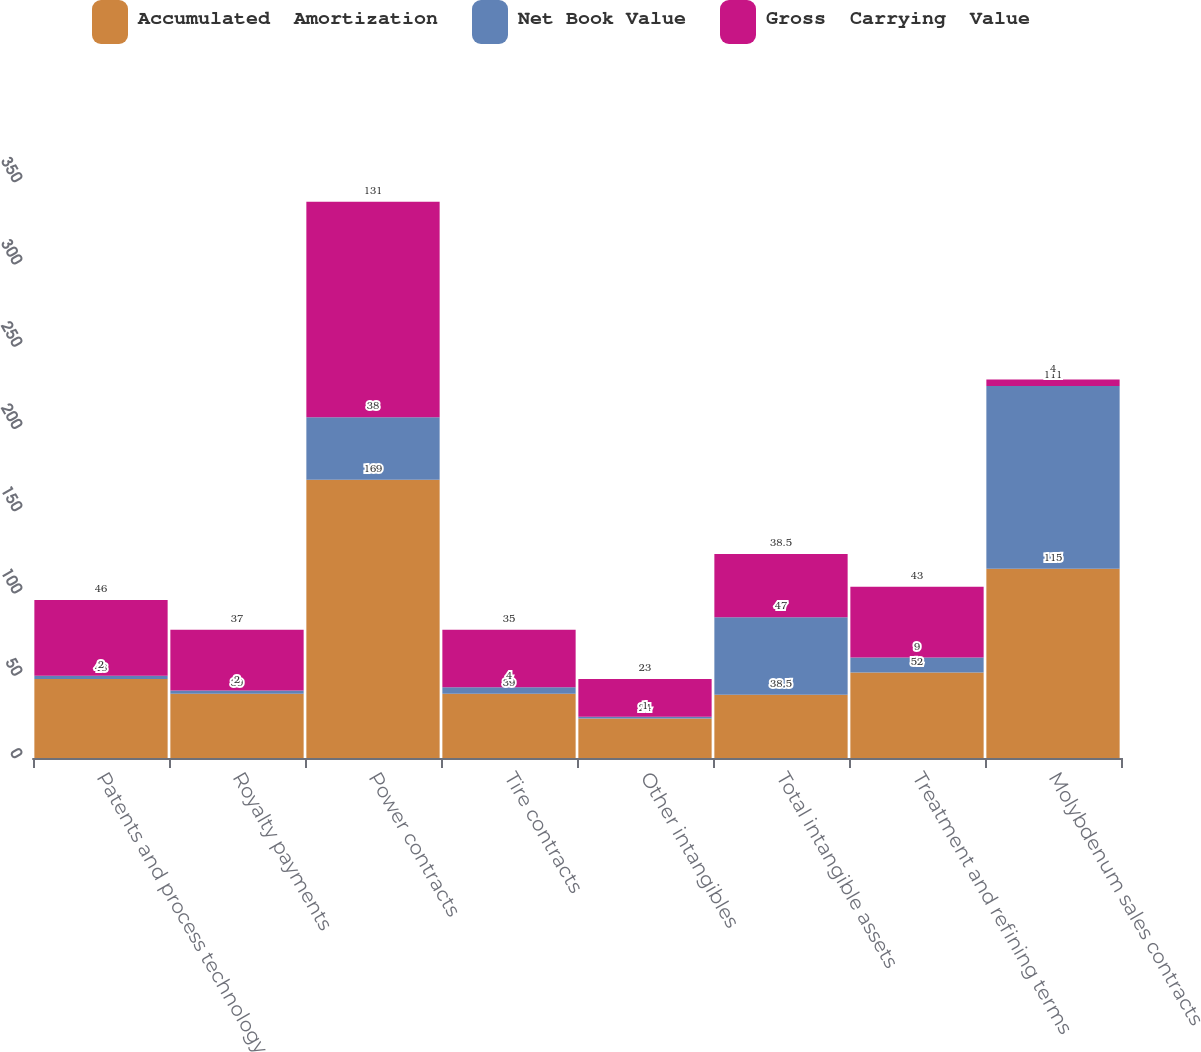Convert chart. <chart><loc_0><loc_0><loc_500><loc_500><stacked_bar_chart><ecel><fcel>Patents and process technology<fcel>Royalty payments<fcel>Power contracts<fcel>Tire contracts<fcel>Other intangibles<fcel>Total intangible assets<fcel>Treatment and refining terms<fcel>Molybdenum sales contracts<nl><fcel>Accumulated  Amortization<fcel>48<fcel>39<fcel>169<fcel>39<fcel>24<fcel>38.5<fcel>52<fcel>115<nl><fcel>Net Book Value<fcel>2<fcel>2<fcel>38<fcel>4<fcel>1<fcel>47<fcel>9<fcel>111<nl><fcel>Gross  Carrying  Value<fcel>46<fcel>37<fcel>131<fcel>35<fcel>23<fcel>38.5<fcel>43<fcel>4<nl></chart> 